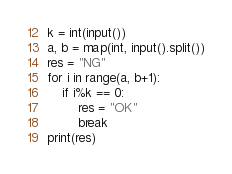<code> <loc_0><loc_0><loc_500><loc_500><_Python_>k = int(input())
a, b = map(int, input().split())
res = "NG"
for i in range(a, b+1):
    if i%k == 0:
        res = "OK"
        break
print(res)</code> 